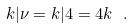<formula> <loc_0><loc_0><loc_500><loc_500>k | \nu = k | 4 = 4 k \ .</formula> 